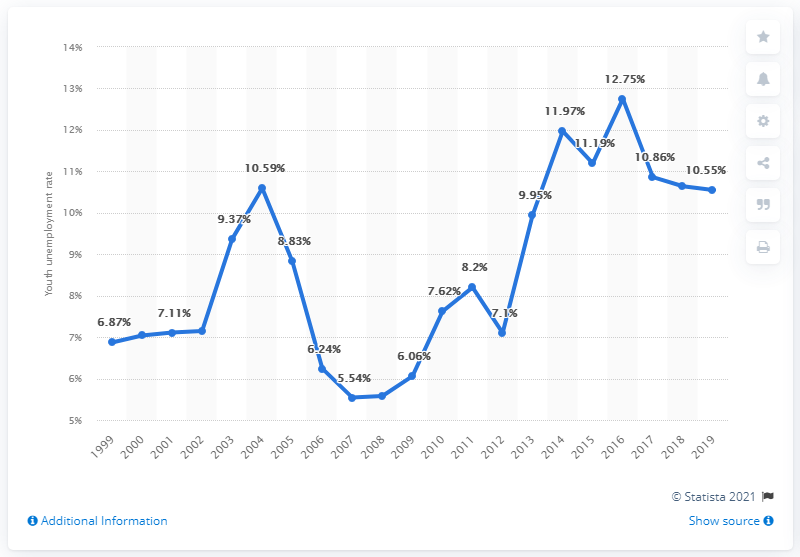Give some essential details in this illustration. The youth unemployment rate in Honduras was 10.55% in 2019. 